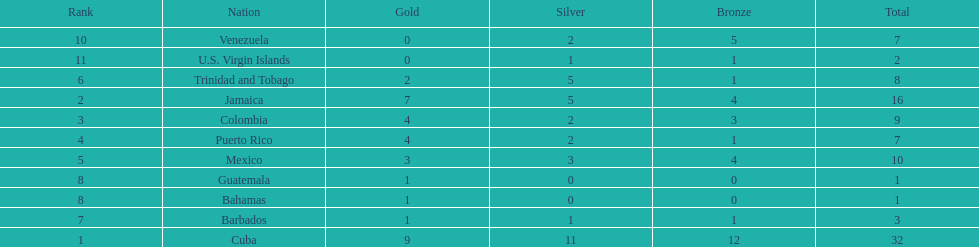Only team to have more than 30 medals Cuba. 